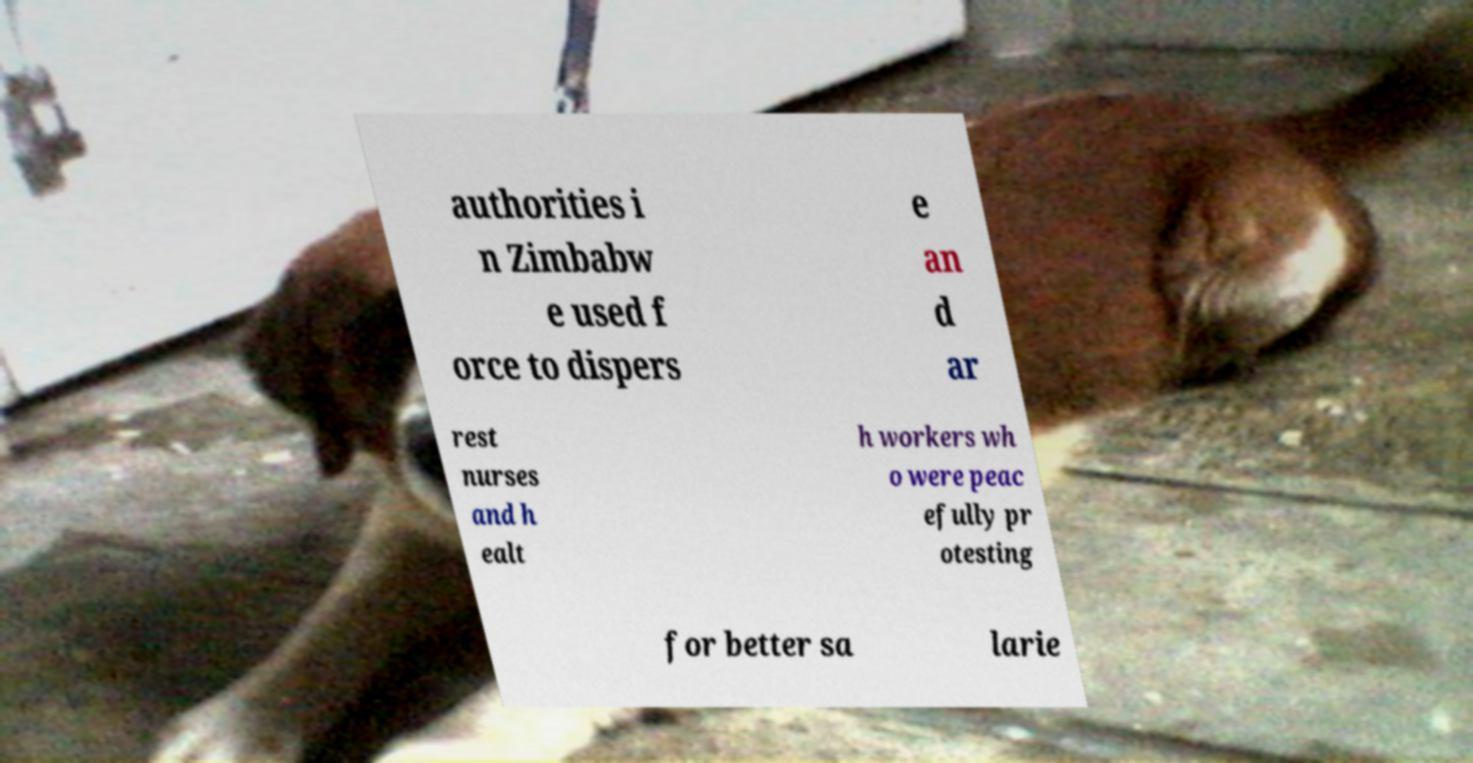There's text embedded in this image that I need extracted. Can you transcribe it verbatim? authorities i n Zimbabw e used f orce to dispers e an d ar rest nurses and h ealt h workers wh o were peac efully pr otesting for better sa larie 